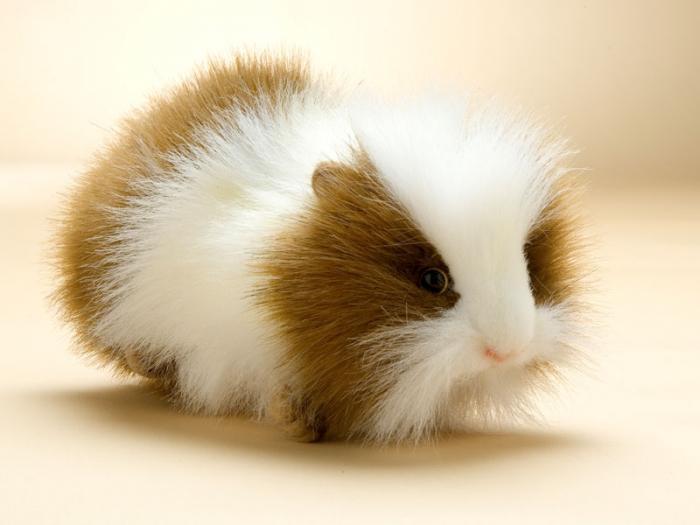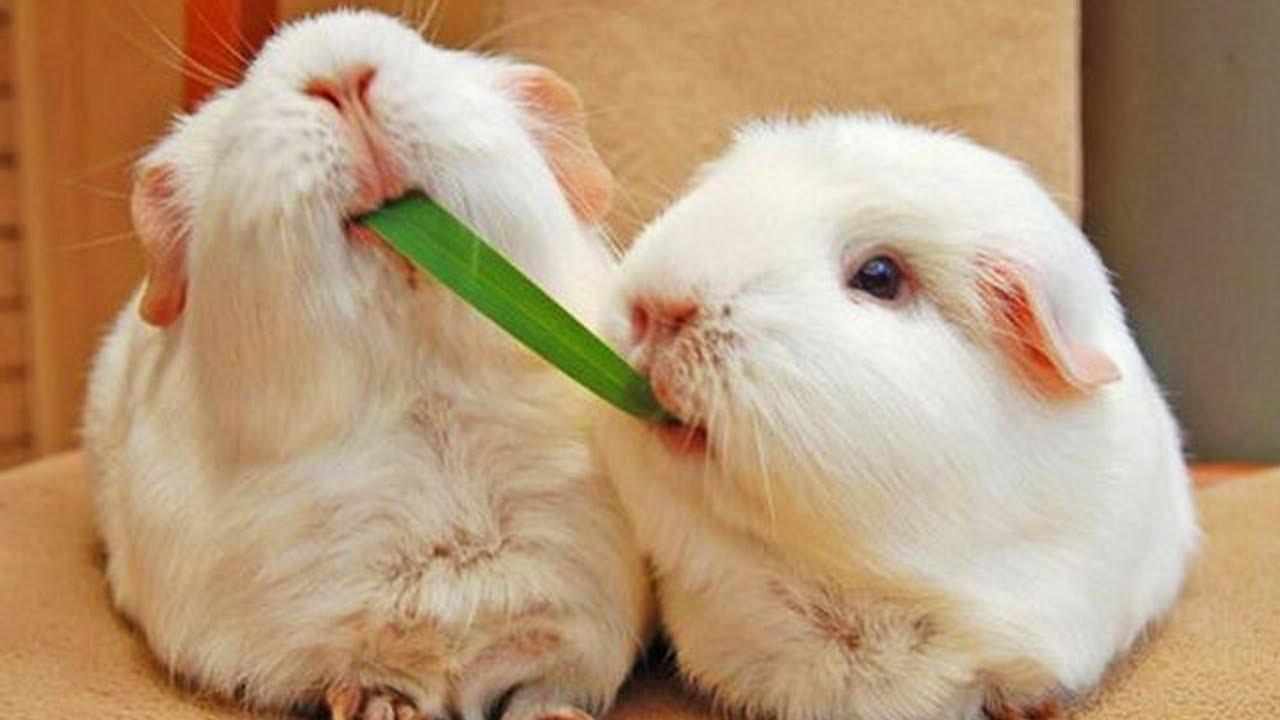The first image is the image on the left, the second image is the image on the right. Examine the images to the left and right. Is the description "There is at least one Guinea pig with an object in it's mouth." accurate? Answer yes or no. Yes. The first image is the image on the left, the second image is the image on the right. Evaluate the accuracy of this statement regarding the images: "Each image contains exactly one guinea pig figure, and one image shows a guinea pig on a plush white textured fabric.". Is it true? Answer yes or no. No. 